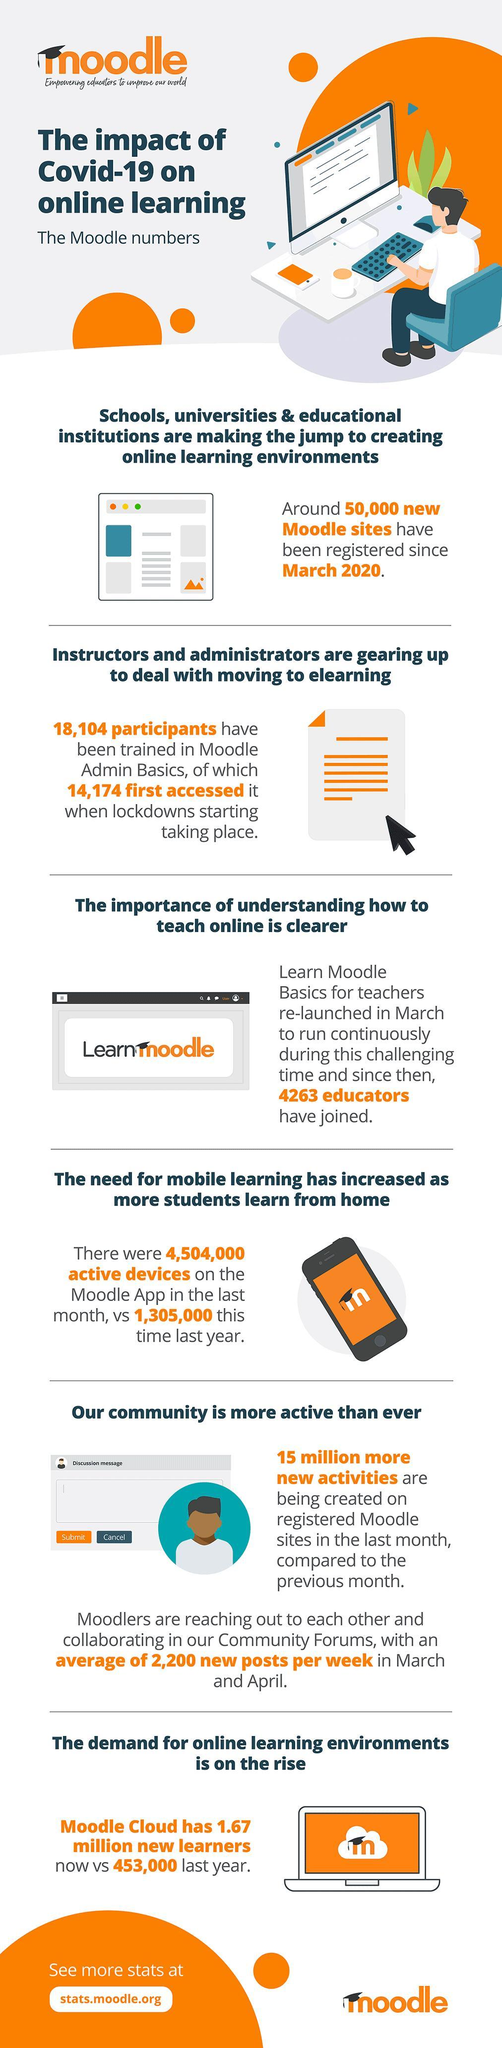What no of people used Moodle Admin Basics before the start of pandemic lockdown?
Answer the question with a short phrase. 3930 How much is the increase in no of active users on the Moodle App in the last month and previous year? 3199000 